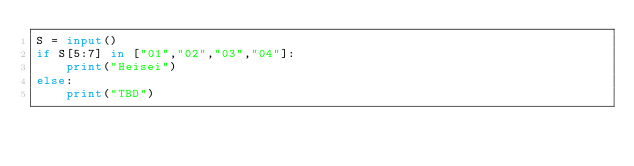<code> <loc_0><loc_0><loc_500><loc_500><_Python_>S = input()
if S[5:7] in ["01","02","03","04"]:
    print("Heisei")
else:
    print("TBD")

</code> 